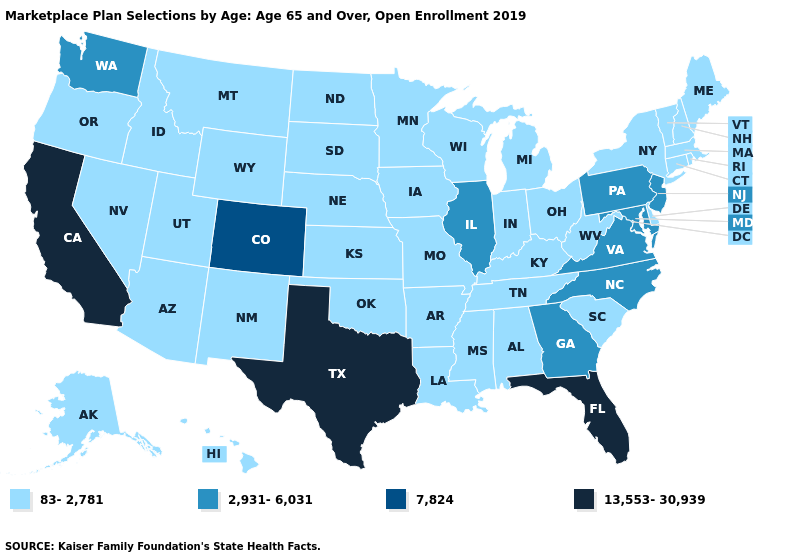Does the map have missing data?
Keep it brief. No. What is the value of Iowa?
Short answer required. 83-2,781. Name the states that have a value in the range 83-2,781?
Be succinct. Alabama, Alaska, Arizona, Arkansas, Connecticut, Delaware, Hawaii, Idaho, Indiana, Iowa, Kansas, Kentucky, Louisiana, Maine, Massachusetts, Michigan, Minnesota, Mississippi, Missouri, Montana, Nebraska, Nevada, New Hampshire, New Mexico, New York, North Dakota, Ohio, Oklahoma, Oregon, Rhode Island, South Carolina, South Dakota, Tennessee, Utah, Vermont, West Virginia, Wisconsin, Wyoming. What is the highest value in states that border Vermont?
Answer briefly. 83-2,781. Name the states that have a value in the range 2,931-6,031?
Write a very short answer. Georgia, Illinois, Maryland, New Jersey, North Carolina, Pennsylvania, Virginia, Washington. Does Illinois have the highest value in the MidWest?
Write a very short answer. Yes. Name the states that have a value in the range 13,553-30,939?
Short answer required. California, Florida, Texas. Does Michigan have the lowest value in the USA?
Write a very short answer. Yes. Among the states that border New Hampshire , which have the highest value?
Answer briefly. Maine, Massachusetts, Vermont. What is the lowest value in states that border Oklahoma?
Quick response, please. 83-2,781. Name the states that have a value in the range 7,824?
Concise answer only. Colorado. Does Wisconsin have the lowest value in the MidWest?
Be succinct. Yes. What is the value of Indiana?
Short answer required. 83-2,781. Does the map have missing data?
Answer briefly. No. Is the legend a continuous bar?
Short answer required. No. 